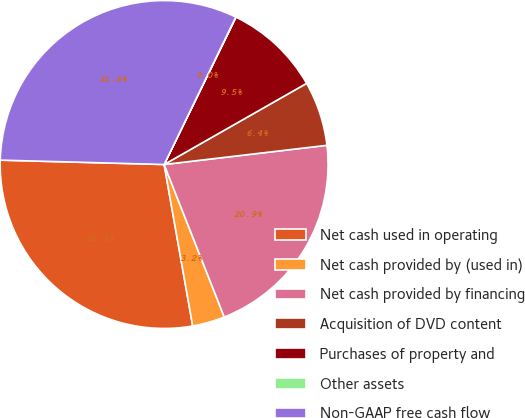<chart> <loc_0><loc_0><loc_500><loc_500><pie_chart><fcel>Net cash used in operating<fcel>Net cash provided by (used in)<fcel>Net cash provided by financing<fcel>Acquisition of DVD content<fcel>Purchases of property and<fcel>Other assets<fcel>Non-GAAP free cash flow<nl><fcel>28.21%<fcel>3.19%<fcel>20.89%<fcel>6.37%<fcel>9.54%<fcel>0.02%<fcel>31.77%<nl></chart> 